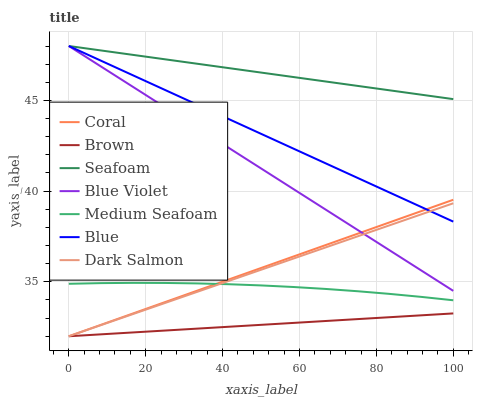Does Brown have the minimum area under the curve?
Answer yes or no. Yes. Does Seafoam have the maximum area under the curve?
Answer yes or no. Yes. Does Coral have the minimum area under the curve?
Answer yes or no. No. Does Coral have the maximum area under the curve?
Answer yes or no. No. Is Blue the smoothest?
Answer yes or no. Yes. Is Medium Seafoam the roughest?
Answer yes or no. Yes. Is Brown the smoothest?
Answer yes or no. No. Is Brown the roughest?
Answer yes or no. No. Does Brown have the lowest value?
Answer yes or no. Yes. Does Seafoam have the lowest value?
Answer yes or no. No. Does Blue Violet have the highest value?
Answer yes or no. Yes. Does Coral have the highest value?
Answer yes or no. No. Is Medium Seafoam less than Blue?
Answer yes or no. Yes. Is Blue greater than Medium Seafoam?
Answer yes or no. Yes. Does Dark Salmon intersect Medium Seafoam?
Answer yes or no. Yes. Is Dark Salmon less than Medium Seafoam?
Answer yes or no. No. Is Dark Salmon greater than Medium Seafoam?
Answer yes or no. No. Does Medium Seafoam intersect Blue?
Answer yes or no. No. 